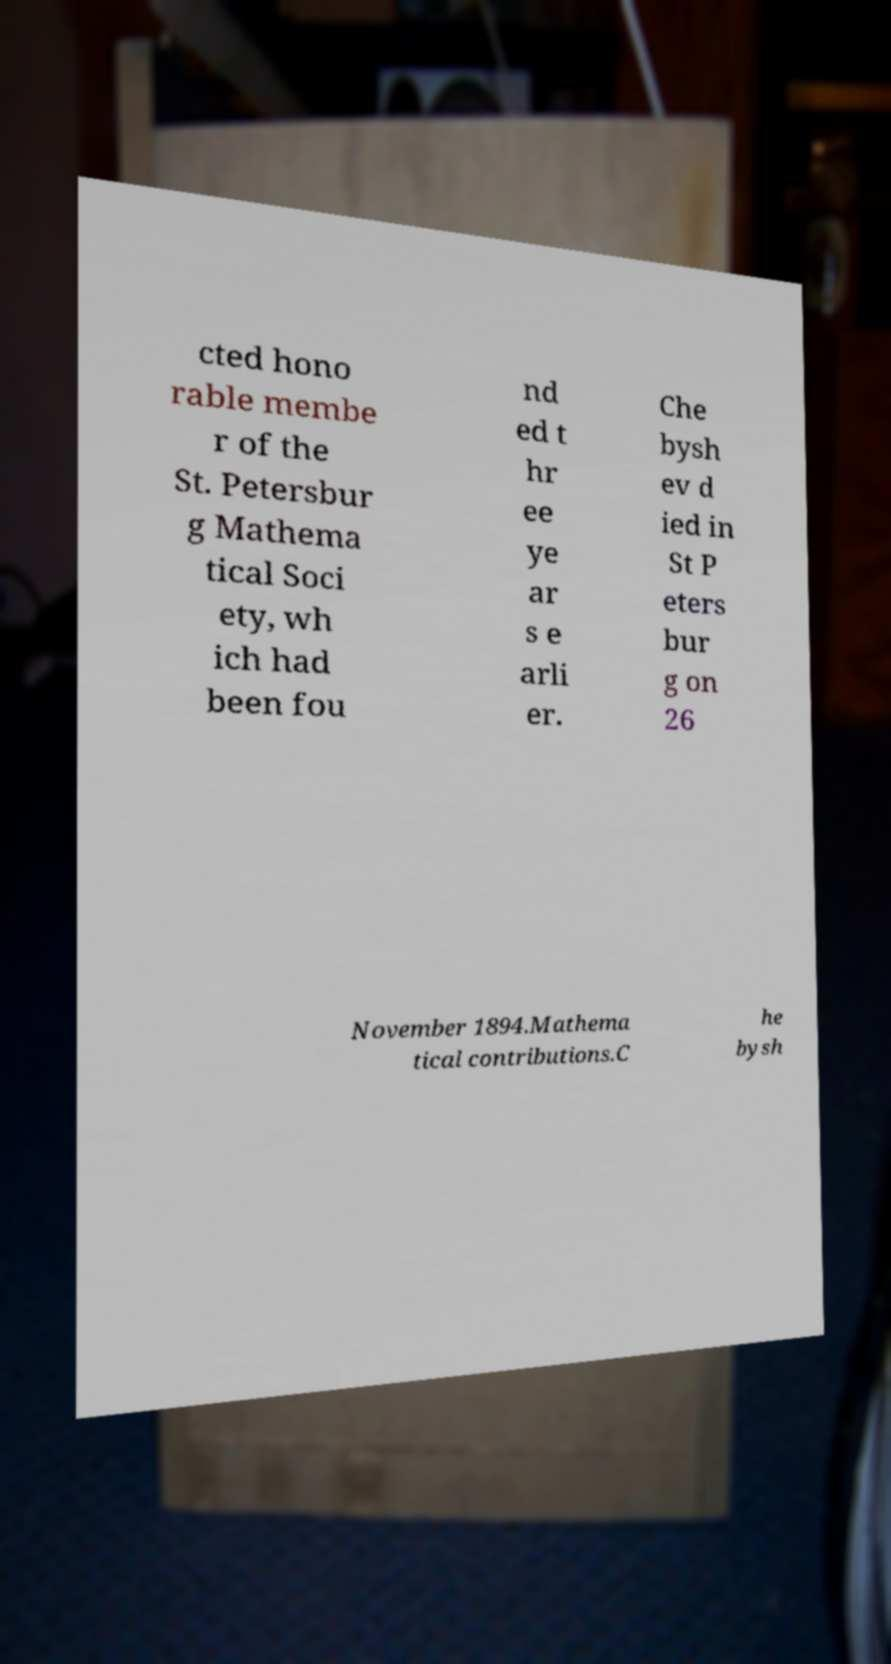Please read and relay the text visible in this image. What does it say? cted hono rable membe r of the St. Petersbur g Mathema tical Soci ety, wh ich had been fou nd ed t hr ee ye ar s e arli er. Che bysh ev d ied in St P eters bur g on 26 November 1894.Mathema tical contributions.C he bysh 